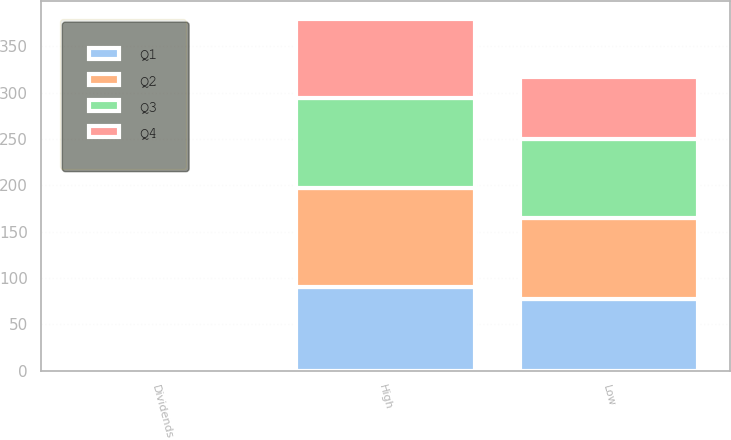Convert chart. <chart><loc_0><loc_0><loc_500><loc_500><stacked_bar_chart><ecel><fcel>Dividends<fcel>High<fcel>Low<nl><fcel>Q4<fcel>0.55<fcel>85.3<fcel>67.06<nl><fcel>Q1<fcel>0.55<fcel>90.14<fcel>77.29<nl><fcel>Q3<fcel>0.55<fcel>98<fcel>86.01<nl><fcel>Q2<fcel>0.6<fcel>106.62<fcel>87.06<nl></chart> 